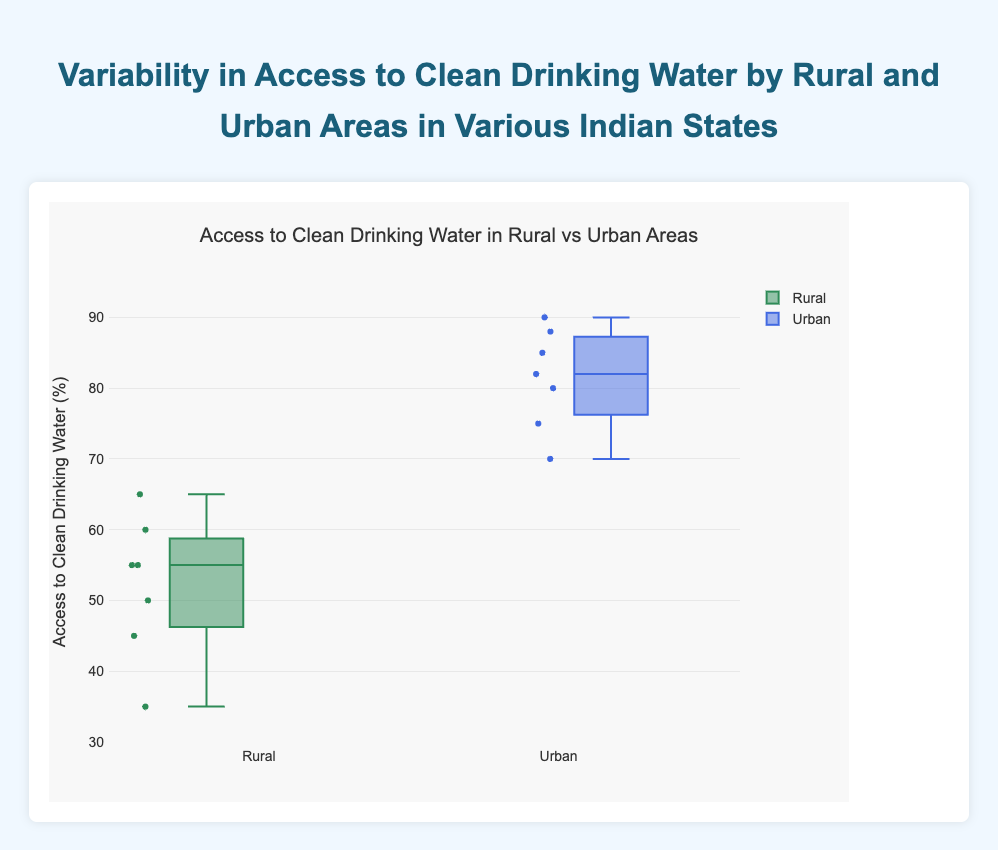What is the title of the chart? The title of the chart is "Access to Clean Drinking Water in Rural vs Urban Areas", which is visible at the top of the chart.
Answer: Access to Clean Drinking Water in Rural vs Urban Areas How many data points are represented for rural areas? The box plot for rural areas shows individual data points as dots. By counting these dots in the rural box plot, we can confirm that there are 6 data points.
Answer: 6 Which region generally has better access to clean drinking water? By comparing the median values in the box plots for rural and urban areas, one can see that the median value for urban areas is higher than that for rural areas, indicating better access.
Answer: Urban areas What is the range of access to clean drinking water percentage in rural areas? The range is the difference between the maximum and minimum values. For rural areas, the minimum value is 35% (Bihar) and the maximum is 65% (Kerala), so the range is 65% - 35% = 30%.
Answer: 30% Which state has the lowest access to clean drinking water in rural areas? Referring to the points in the box plot for rural areas, the lowest point corresponds to Bihar with 35% access.
Answer: Bihar What is the difference in median access to clean drinking water between rural and urban areas? The median for rural areas is approximately 55%, and for urban areas, it is around 80%. The difference is 80% - 55% = 25%.
Answer: 25% Which state has the highest access to clean drinking water in urban areas? Looking at the individual points in the box plot for urban areas, the highest point corresponds to Kerala with 90% access.
Answer: Kerala Is there any overlap in the interquartile ranges (IQRs) of rural and urban areas? The IQRs are the boxes in the box plots. There is no overlap between the IQRs of rural and urban areas, indicating distinct separation in access levels.
Answer: No What is the median access to clean drinking water in rural areas? The median is represented by the central line in the box plot for rural areas. This line is at 55%.
Answer: 55% What is the highest outlier in urban areas? Outliers are the points outside the whiskers. For urban areas, all data points seem to lie within the whiskers, so there are no outliers.
Answer: None 